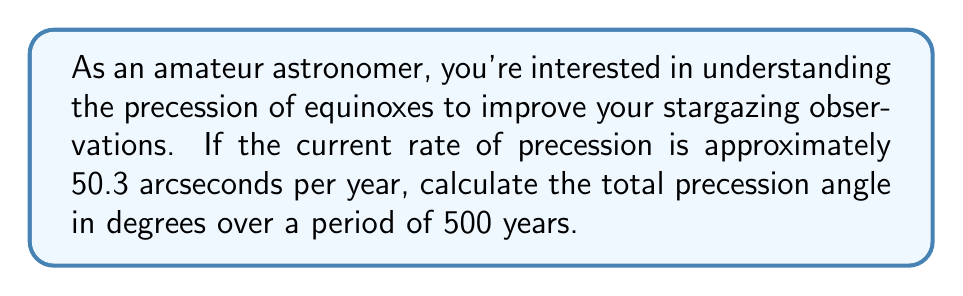Could you help me with this problem? To solve this problem, we need to follow these steps:

1. Convert the rate of precession from arcseconds per year to degrees per year:
   $$ \text{Rate in degrees} = \frac{50.3 \text{ arcseconds}}{3600 \text{ arcseconds/degree}} = 0.013972222 \text{ degrees/year} $$

2. Multiply the rate in degrees per year by the given time interval:
   $$ \text{Total precession} = 0.013972222 \text{ degrees/year} \times 500 \text{ years} $$

3. Perform the calculation:
   $$ \text{Total precession} = 6.9861111 \text{ degrees} $$

4. Round the result to a reasonable number of decimal places (e.g., 2):
   $$ \text{Total precession} \approx 6.99 \text{ degrees} $$

This calculation gives us the total angle through which the equinoxes will precess over 500 years. As an amateur astronomer, understanding this precession is crucial for accurate star positioning over long periods, especially when using historical star catalogs or planning long-term observations.
Answer: The total precession angle over 500 years is approximately $6.99$ degrees. 